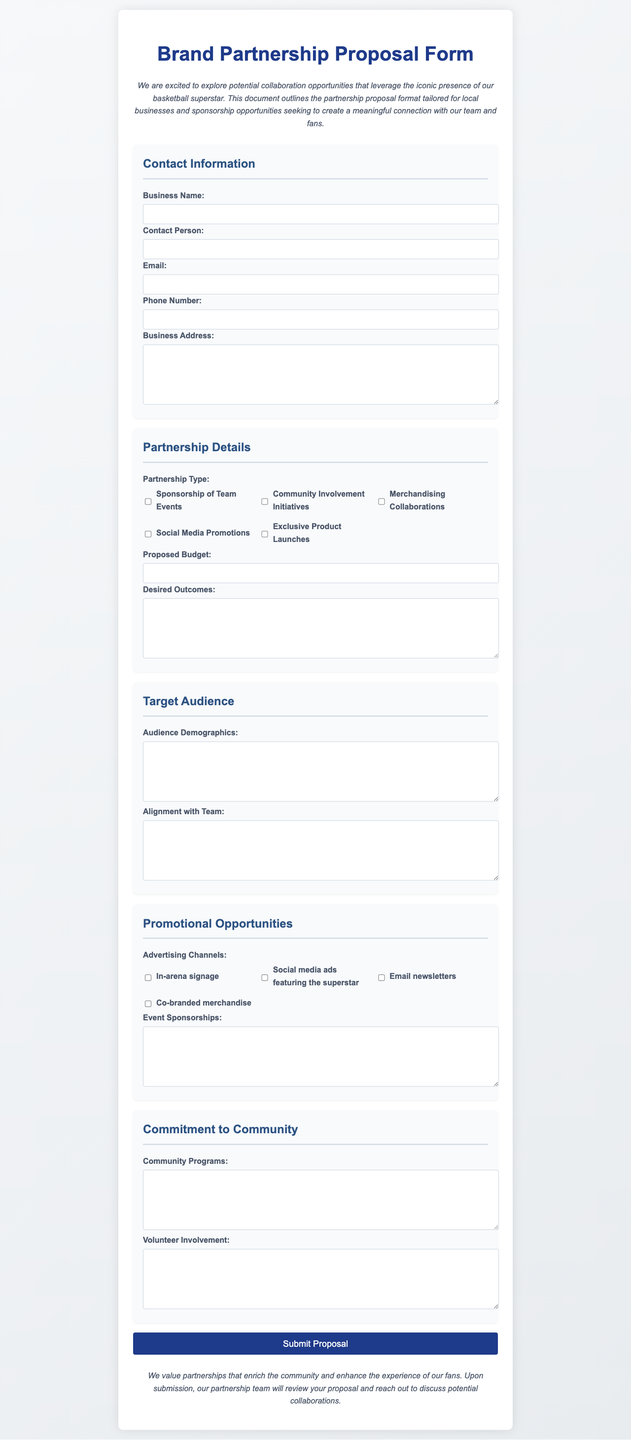What is the title of the document? The title is indicated at the top of the document in a large font.
Answer: Brand Partnership Proposal Form Who is the document intended for? The introduction describes the audience this proposal targets, which includes local businesses and sponsors.
Answer: Local businesses and sponsors What type of advertising channels are listed in the document? The checkboxes under the promotional opportunities section outline various advertising channels.
Answer: In-arena signage, Social media ads featuring the superstar, Email newsletters, Co-branded merchandise What is required in the "Proposed Budget" section? It specifies that this information needs to be filled out by the submitting party.
Answer: Proposed budget amount What should be included in the "Desired Outcomes" section? This section seeks the responder's information on expectations from the partnership.
Answer: Expected partnership outcomes How many sections are in the form? By counting the main categories outlined in the form, one can determine the number of sections.
Answer: Five What does the closing statement emphasize regarding partnerships? The closing statement expresses the document's commitment to community engagement.
Answer: Community enrichment and fan experience What kind of person should be mentioned in the "Contact Information"? The form explicitly mentions a contact role in the business involved in the partnership.
Answer: Contact Person What type of initiatives does the proposal encourage through partnerships? The document encourages various partnership types to benefit the community.
Answer: Community Involvement Initiatives 